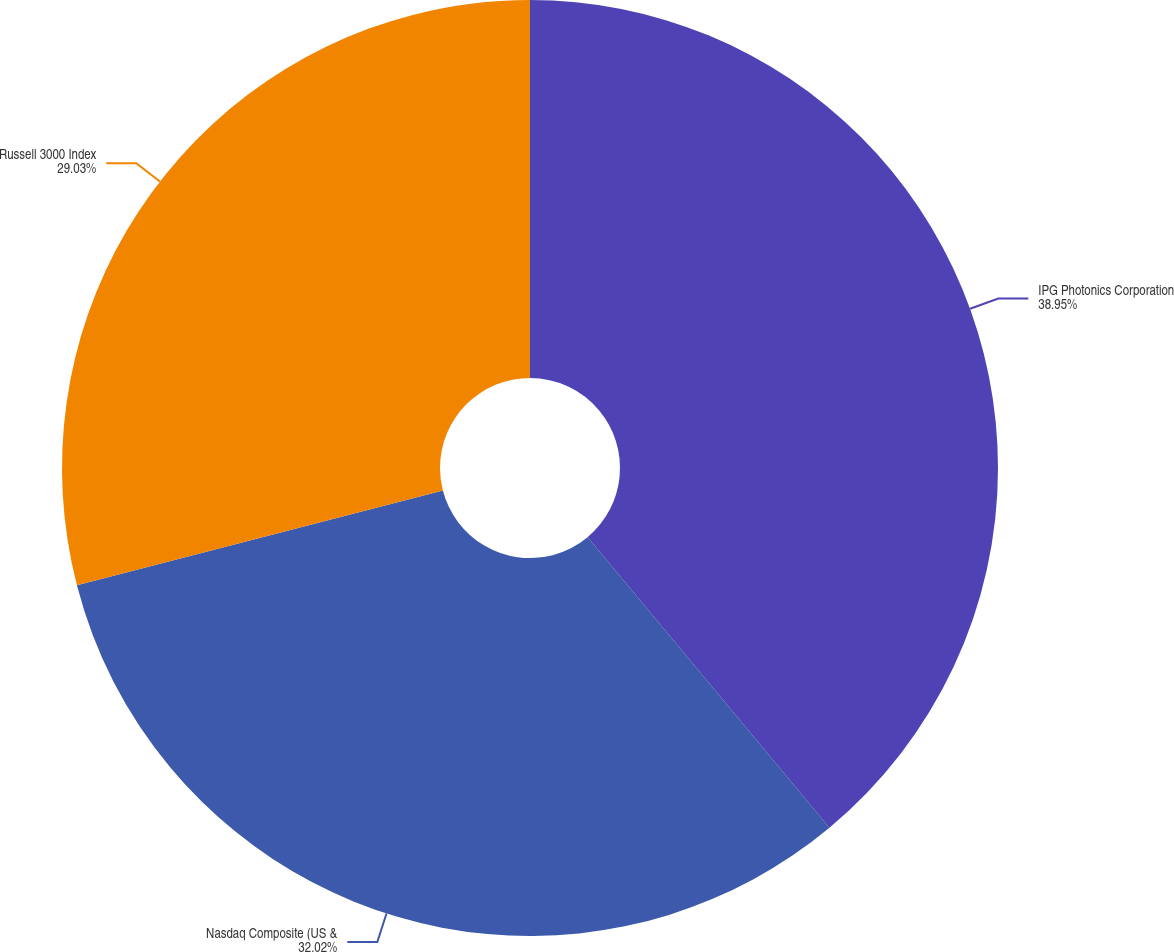Convert chart. <chart><loc_0><loc_0><loc_500><loc_500><pie_chart><fcel>IPG Photonics Corporation<fcel>Nasdaq Composite (US &<fcel>Russell 3000 Index<nl><fcel>38.95%<fcel>32.02%<fcel>29.03%<nl></chart> 